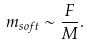Convert formula to latex. <formula><loc_0><loc_0><loc_500><loc_500>m _ { s o f t } \sim \frac { F } { M } .</formula> 